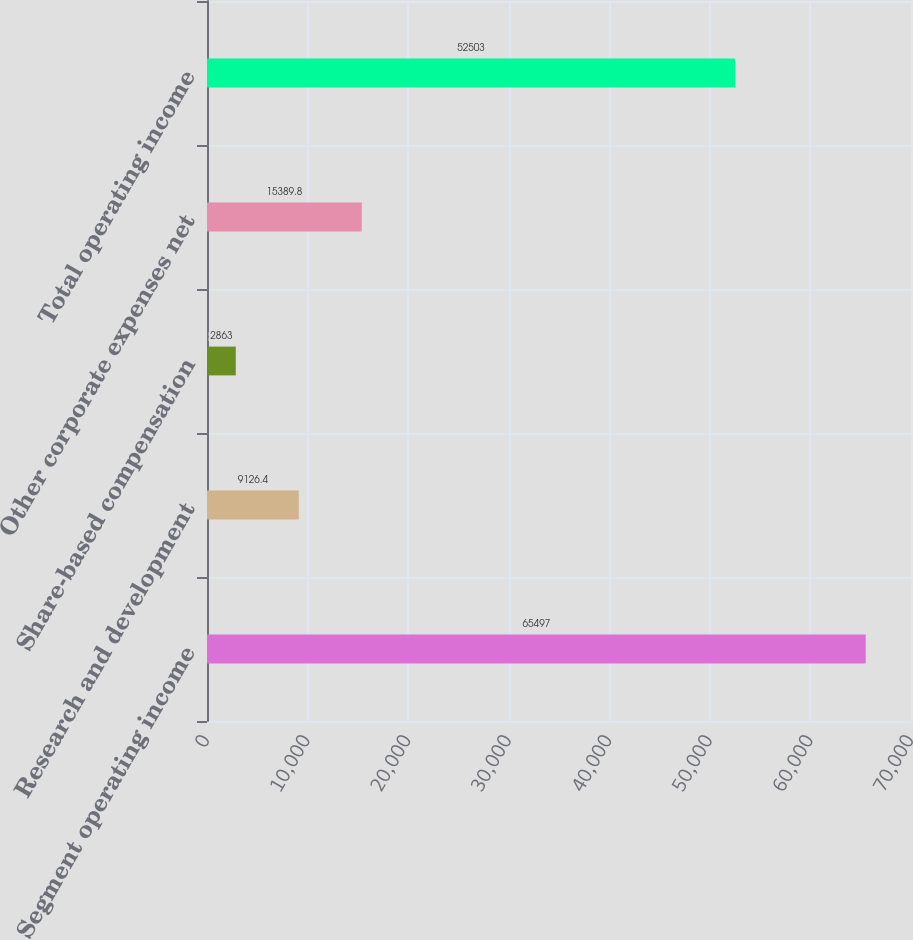Convert chart to OTSL. <chart><loc_0><loc_0><loc_500><loc_500><bar_chart><fcel>Segment operating income<fcel>Research and development<fcel>Share-based compensation<fcel>Other corporate expenses net<fcel>Total operating income<nl><fcel>65497<fcel>9126.4<fcel>2863<fcel>15389.8<fcel>52503<nl></chart> 